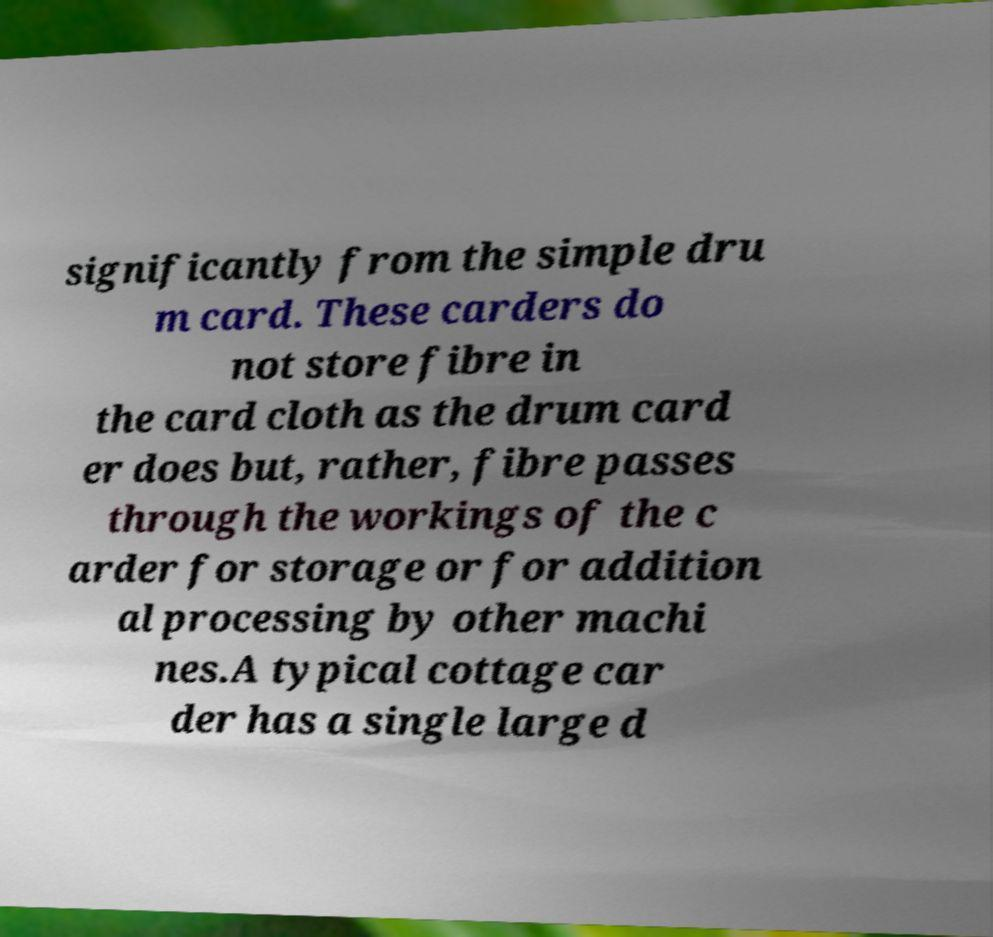What messages or text are displayed in this image? I need them in a readable, typed format. significantly from the simple dru m card. These carders do not store fibre in the card cloth as the drum card er does but, rather, fibre passes through the workings of the c arder for storage or for addition al processing by other machi nes.A typical cottage car der has a single large d 